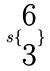Convert formula to latex. <formula><loc_0><loc_0><loc_500><loc_500>s \{ \begin{matrix} 6 \\ 3 \end{matrix} \}</formula> 